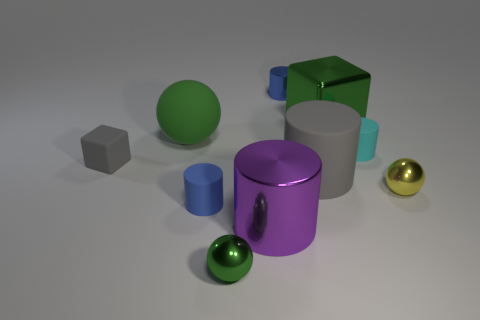What is the material of the other tiny object that is the same shape as the tiny yellow metal object?
Give a very brief answer. Metal. Is there anything else that is the same color as the tiny matte block?
Provide a succinct answer. Yes. Do the blue shiny thing and the gray matte thing to the right of the green rubber sphere have the same shape?
Provide a succinct answer. Yes. What color is the small cylinder that is in front of the tiny matte cylinder right of the tiny blue cylinder on the left side of the purple cylinder?
Ensure brevity in your answer.  Blue. There is a thing behind the green block; is it the same shape as the small blue rubber object?
Make the answer very short. Yes. What is the yellow sphere made of?
Offer a terse response. Metal. What is the shape of the gray object on the left side of the tiny rubber object in front of the cube to the left of the blue matte object?
Offer a terse response. Cube. How many other objects are there of the same shape as the cyan rubber object?
Your response must be concise. 4. Is the color of the large metal cylinder the same as the sphere that is left of the green metallic ball?
Offer a terse response. No. How many purple metallic cubes are there?
Provide a succinct answer. 0. 